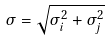<formula> <loc_0><loc_0><loc_500><loc_500>\sigma = \sqrt { \sigma _ { i } ^ { 2 } + \sigma _ { j } ^ { 2 } }</formula> 